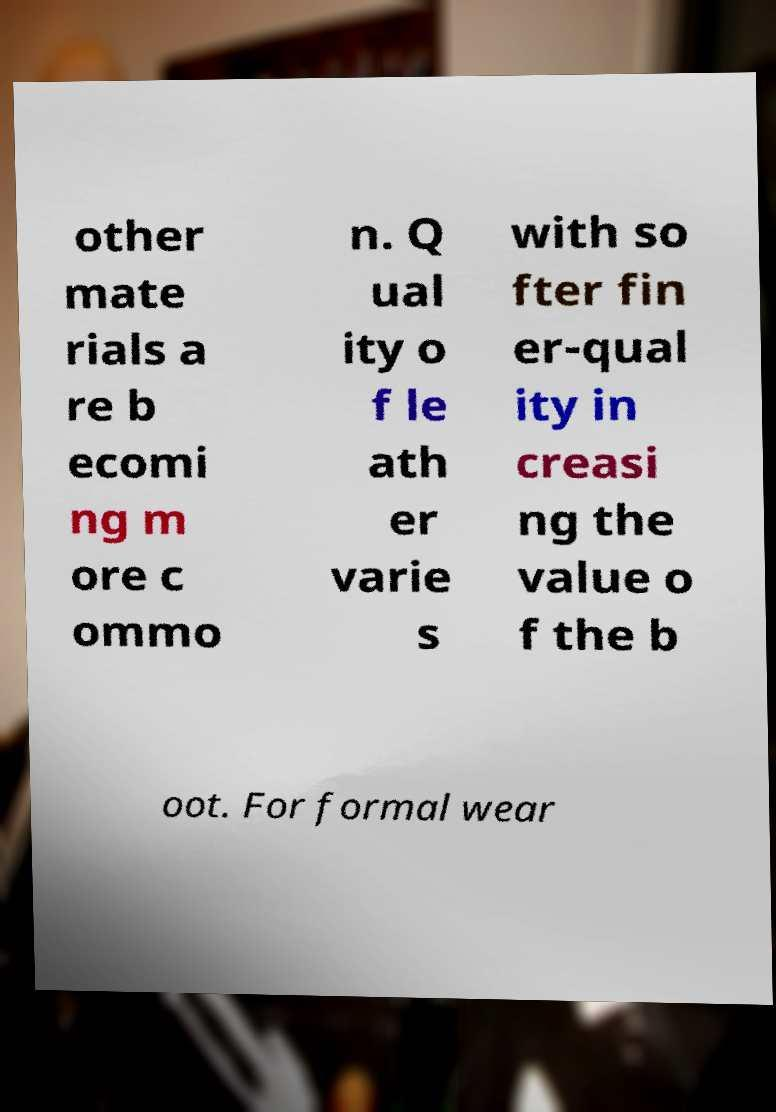There's text embedded in this image that I need extracted. Can you transcribe it verbatim? other mate rials a re b ecomi ng m ore c ommo n. Q ual ity o f le ath er varie s with so fter fin er-qual ity in creasi ng the value o f the b oot. For formal wear 